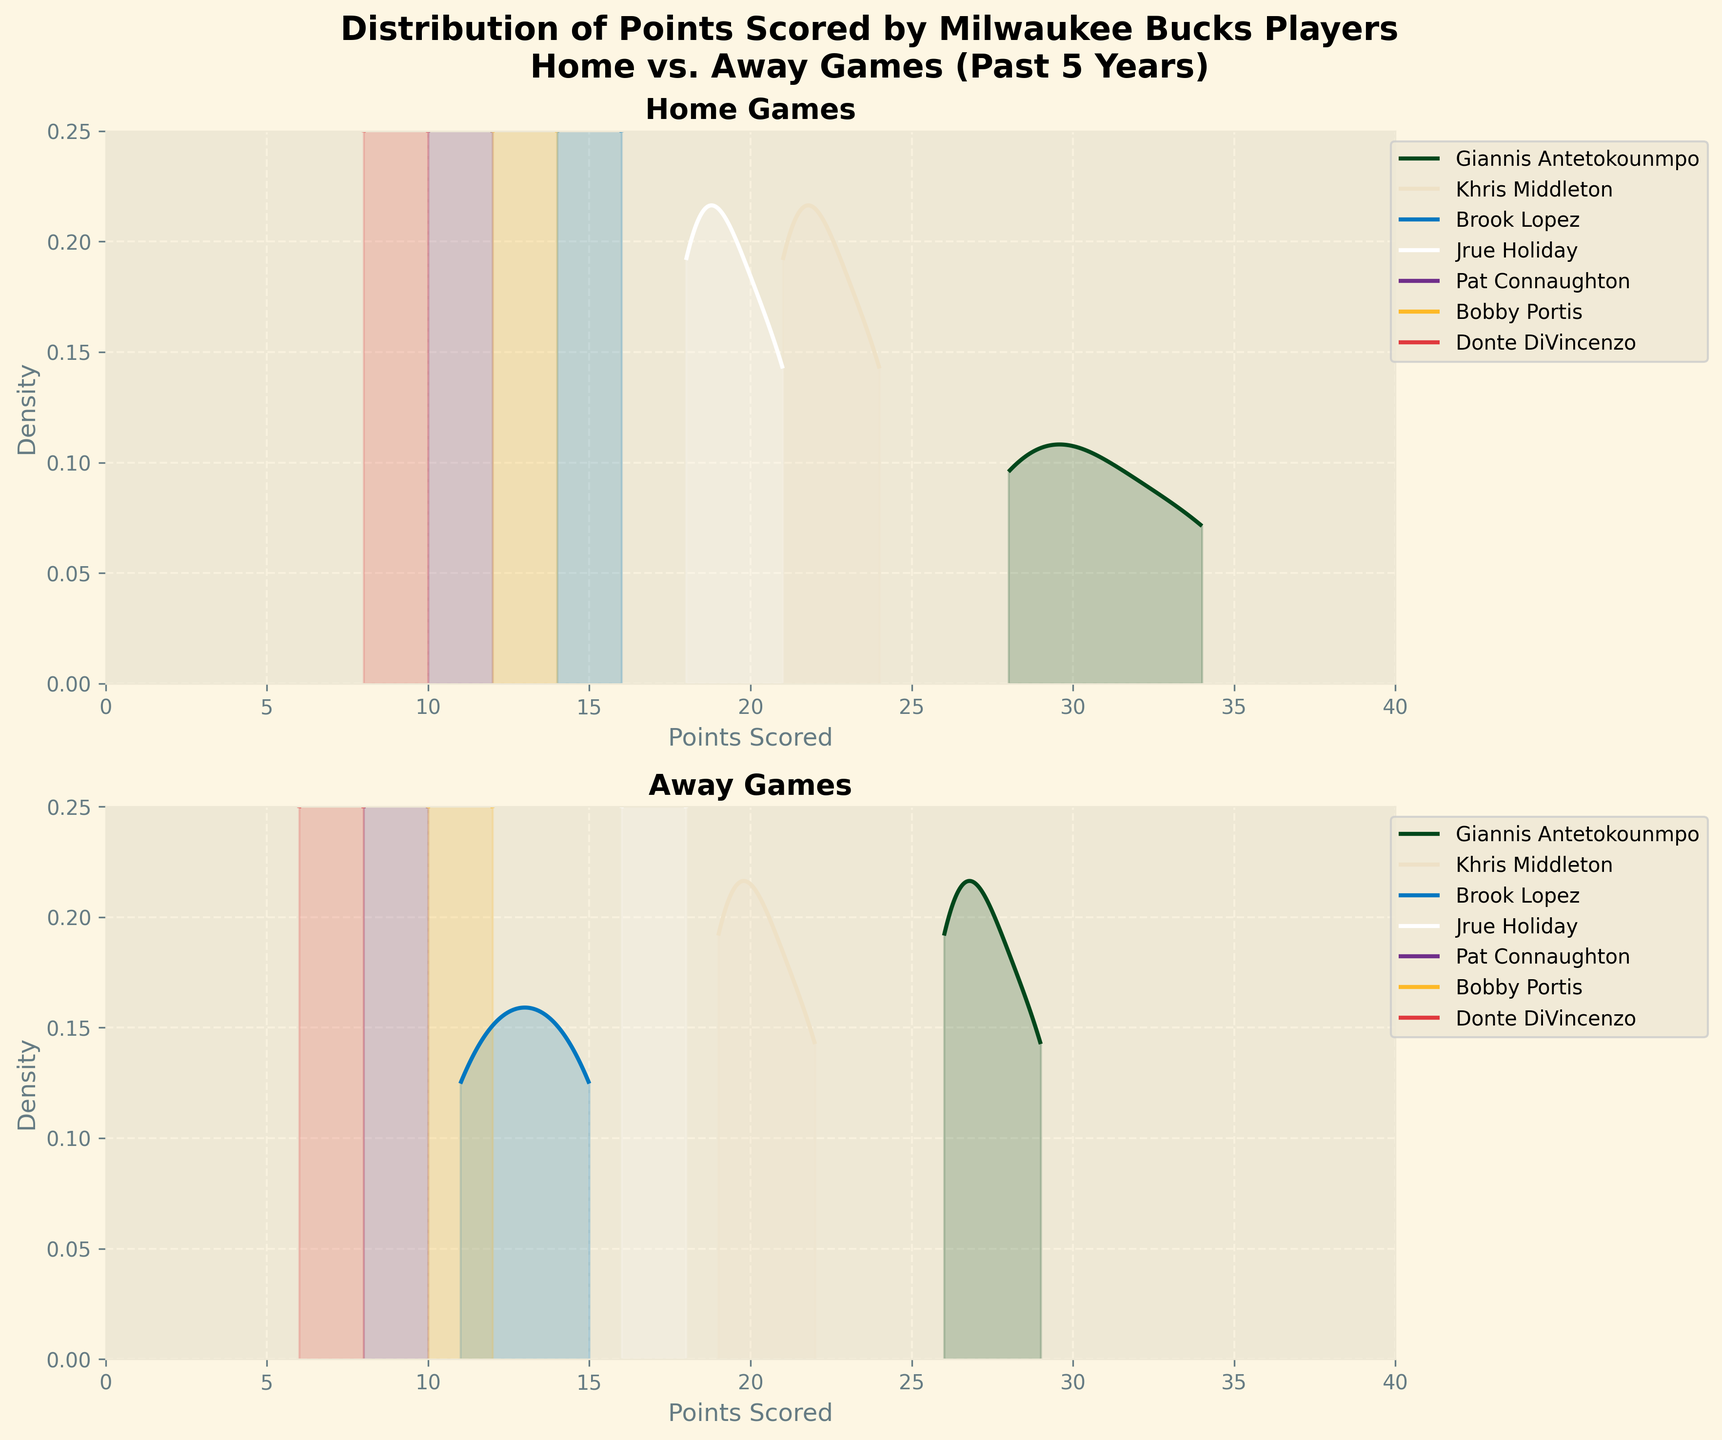Which games have a higher density of points around 30 for Giannis Antetokounmpo? In the home games subplot, the density curve for Giannis Antetokounmpo shows a significant peak around 30 points. In the away games subplot, the density is lower at around 30 points.
Answer: Home games What is the title of the subplot for home games? The title of the top subplot indicates the focus on home game performances. It is found at the top of the subplot.
Answer: Home Games Which player has the highest density peak in away games? Look at the second subplot labeled "Away Games." The player curve with the highest peak shows who scores the most consistently in away games. Giannis Antetokounmpo’s curve has the most prominent peak.
Answer: Giannis Antetokounmpo Compare the density of points scored by Khris Middleton in home vs. away games. Which has a higher peak? Comparing the density plots for Khris Middleton in both the home and away subplots, the home subplot shows a higher peak, indicating a more consistent scoring range.
Answer: Home games Which player’s scoring density appears most shifted towards the lower end in away games? The subplot for away games should be examined to identify the density curve that is shifted more towards the lower points range. Donte DiVincenzo’s curve in the away subplot is more shifted to the left.
Answer: Donte DiVincenzo In which subplot do you observe more varied densities among the players? By comparing the two subplots, one can observe that the home subplot has less variation among the players’ density curves while the away subplot shows more varied density shapes and peaks.
Answer: Away games Which player's density curve appears the widest in the home games subplot? The width of a density curve indicates the range over which a player’s scores are spread. In the home games subplot, Giannis Antetokounmpo's density curve appears the widest, suggesting a broader range of scoring in home games.
Answer: Giannis Antetokounmpo Is there any player whose scoring density in away games never exceeds 15 points? To determine this, check the away subplot and observe if any player’s density curve completely lies below 15 points. Donte DiVincenzo’s density curve only includes points below 15.
Answer: Donte DiVincenzo What’s the maximum density value reached by Giannis Antetokounmpo in home games? The peak of Giannis Antetokounmpo's density curve in the home subplot gives the maximum density value. The peak appears to be around 0.18.
Answer: 0.18 